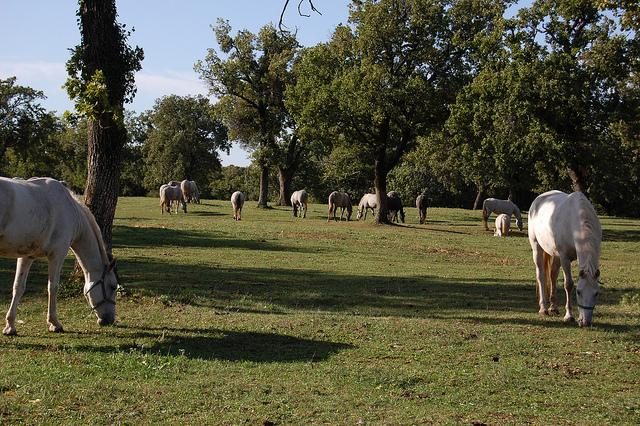What animals are present? horses 